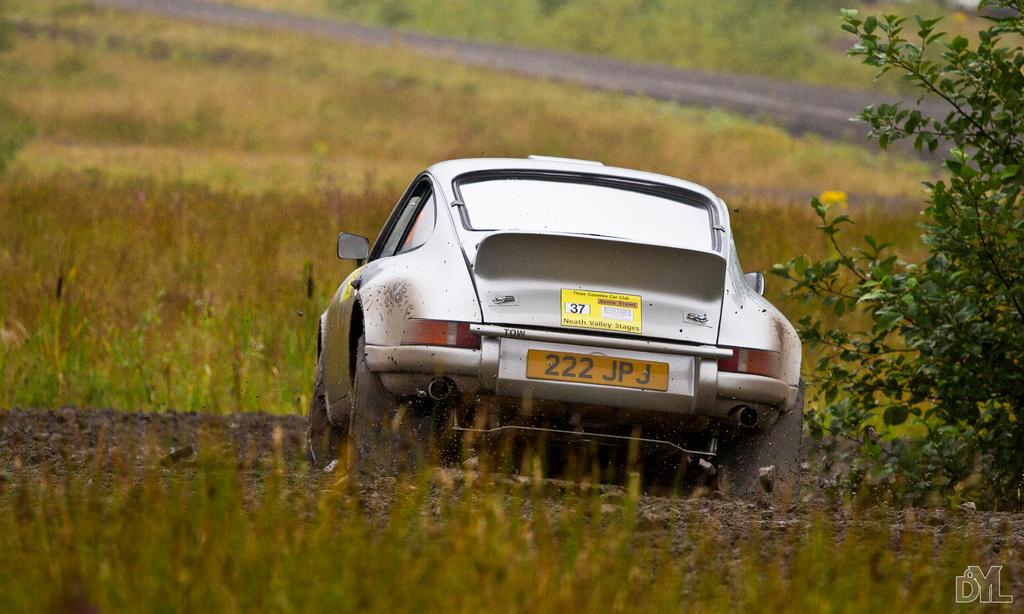What type of vehicle is in the image? There is a silver-colored car in the image. What is the car doing in the image? The car is moving on the grass. What can be seen on the right side of the image? There is a plant on the right side of the image. What type of terrain is visible in the background of the image? There is grass visible in the background of the image. What type of needle can be seen in the image? There is no needle present in the image. What line is visible in the image? There is no line visible in the image. 